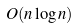<formula> <loc_0><loc_0><loc_500><loc_500>O ( n \log n )</formula> 